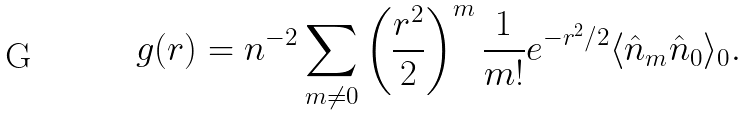Convert formula to latex. <formula><loc_0><loc_0><loc_500><loc_500>g ( r ) = n ^ { - 2 } \sum _ { m \neq 0 } \left ( \frac { r ^ { 2 } } { 2 } \right ) ^ { m } \frac { 1 } { m ! } e ^ { - r ^ { 2 } / 2 } \langle \hat { n } _ { m } \hat { n } _ { 0 } \rangle _ { 0 } .</formula> 